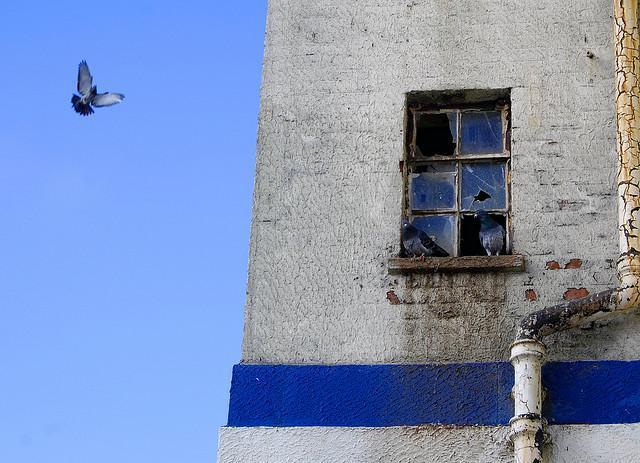How many squares are in the window?
Give a very brief answer. 6. How many umbrellas are pictured?
Give a very brief answer. 0. 